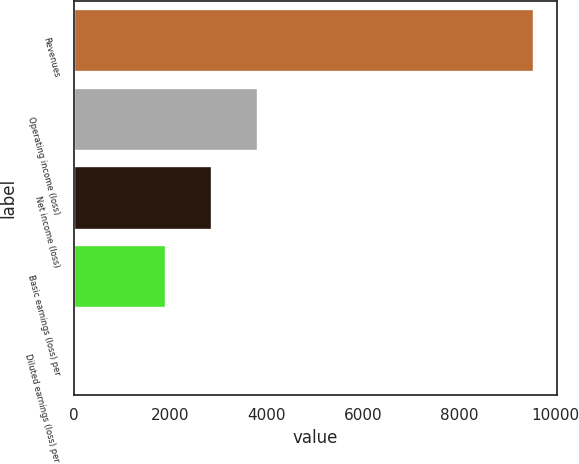Convert chart to OTSL. <chart><loc_0><loc_0><loc_500><loc_500><bar_chart><fcel>Revenues<fcel>Operating income (loss)<fcel>Net income (loss)<fcel>Basic earnings (loss) per<fcel>Diluted earnings (loss) per<nl><fcel>9538<fcel>3816.14<fcel>2862.49<fcel>1908.84<fcel>1.54<nl></chart> 